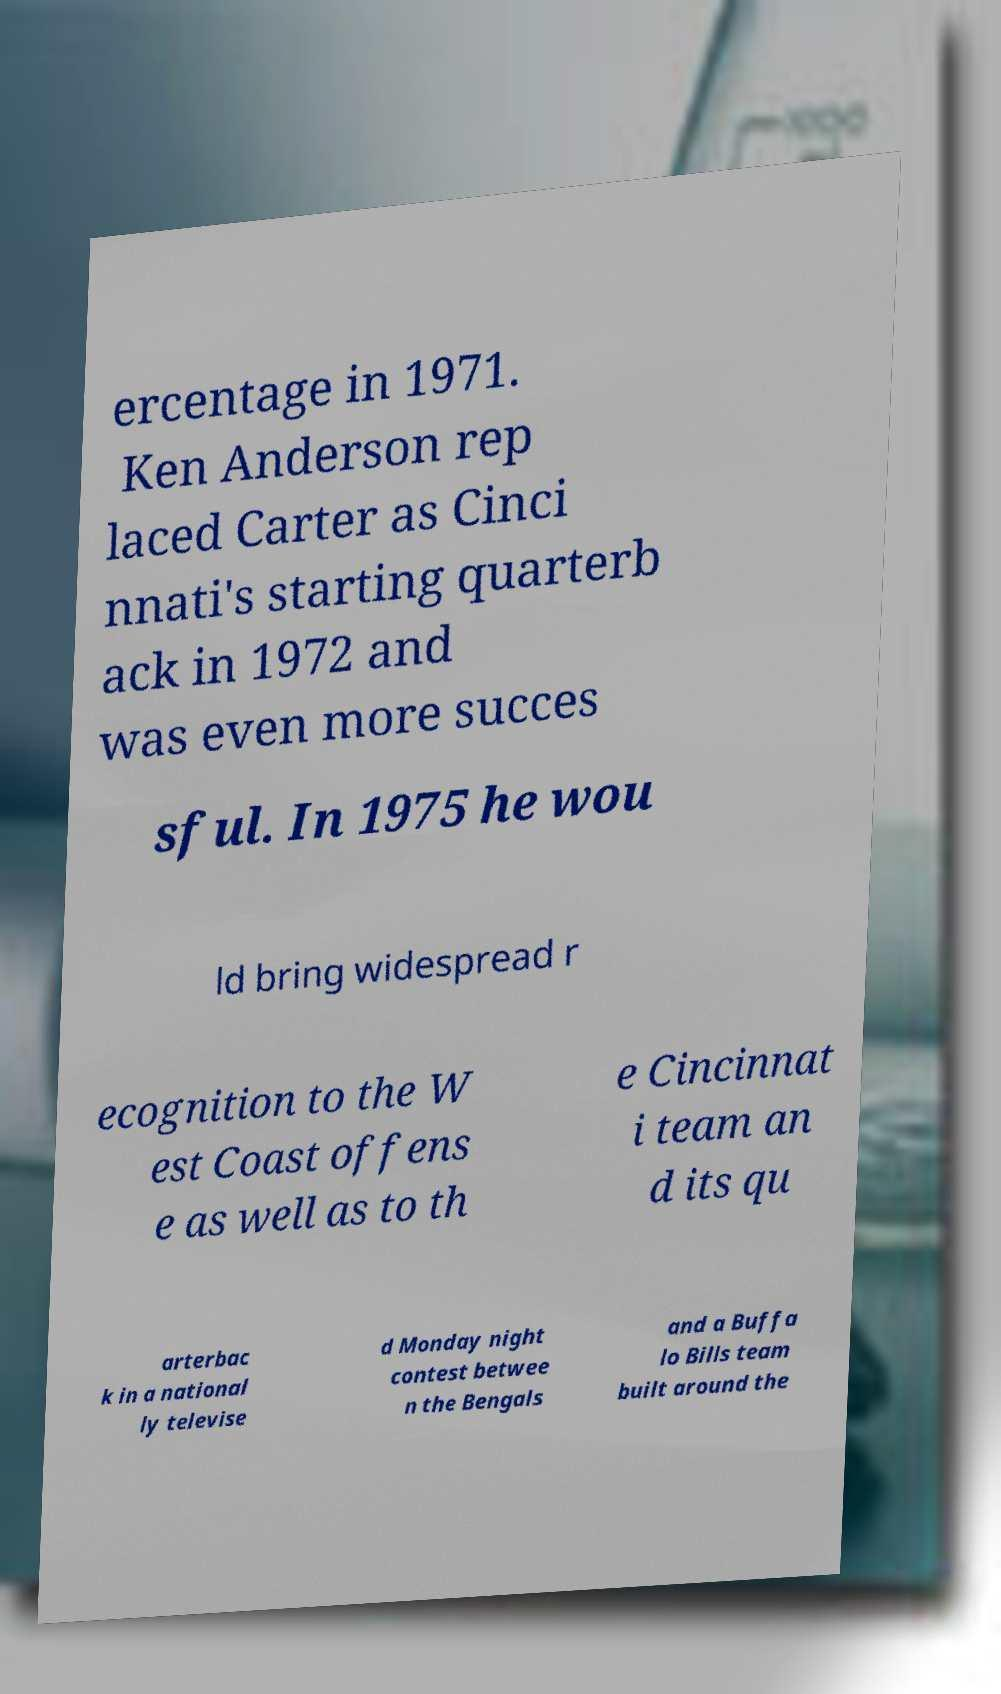I need the written content from this picture converted into text. Can you do that? ercentage in 1971. Ken Anderson rep laced Carter as Cinci nnati's starting quarterb ack in 1972 and was even more succes sful. In 1975 he wou ld bring widespread r ecognition to the W est Coast offens e as well as to th e Cincinnat i team an d its qu arterbac k in a national ly televise d Monday night contest betwee n the Bengals and a Buffa lo Bills team built around the 